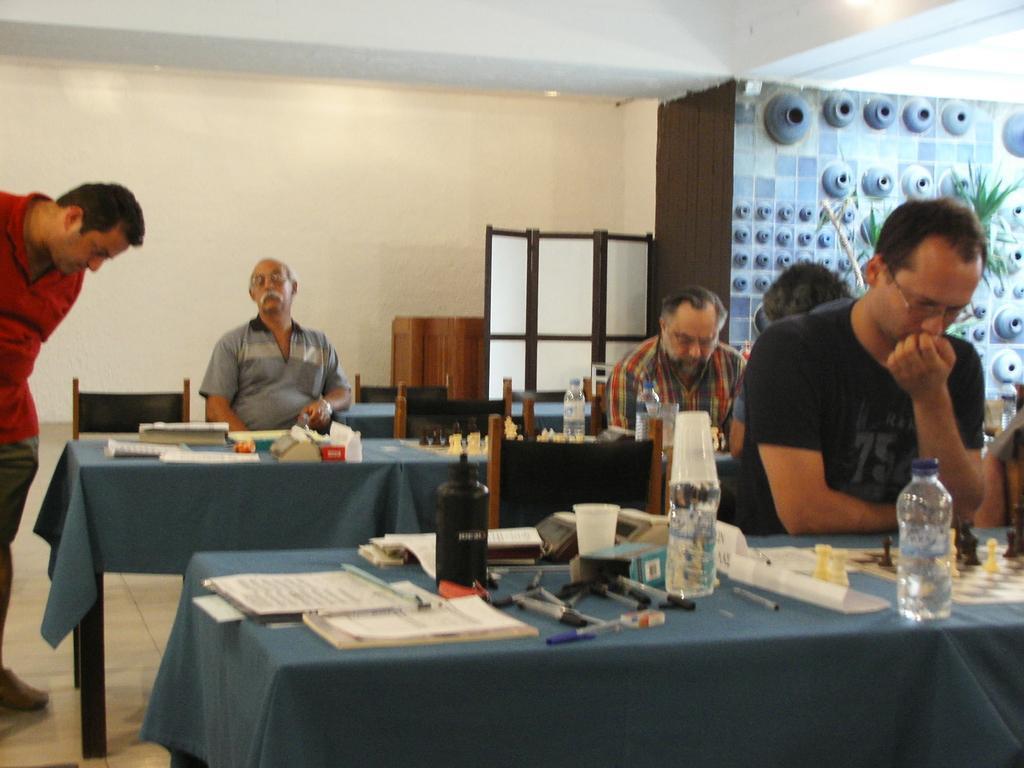Describe this image in one or two sentences. there are tables in which there are tablecloths. on the tables there are chess board, water bottles, glass, papers, pen, boxes. a person is sitting at the right wearing black t shirt. behind him there are 2 more people sitting and playing chess. at the back a person is sitting and wearing grey t shirt. at the left a person is standing wearing a red t shirt. behind them there is a white wall. at the right back there is a wall on which there are plants and blue designs. 